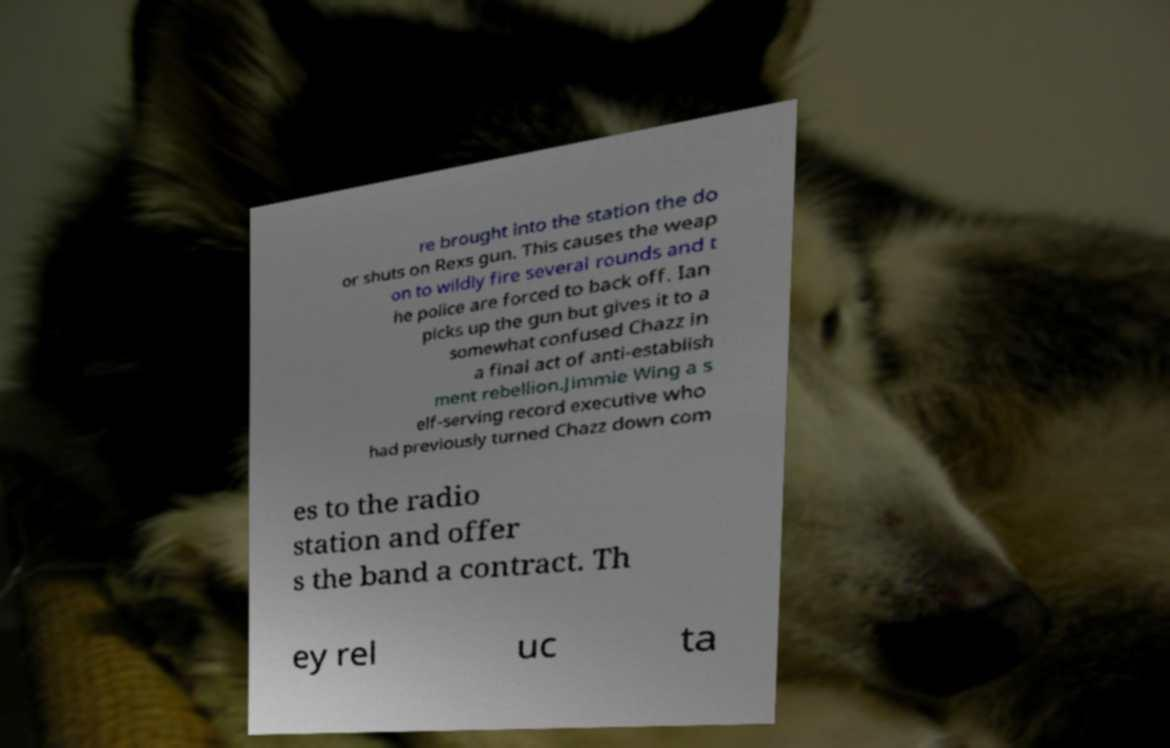What messages or text are displayed in this image? I need them in a readable, typed format. re brought into the station the do or shuts on Rexs gun. This causes the weap on to wildly fire several rounds and t he police are forced to back off. Ian picks up the gun but gives it to a somewhat confused Chazz in a final act of anti-establish ment rebellion.Jimmie Wing a s elf-serving record executive who had previously turned Chazz down com es to the radio station and offer s the band a contract. Th ey rel uc ta 